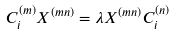<formula> <loc_0><loc_0><loc_500><loc_500>C _ { i } ^ { ( m ) } X ^ { ( m n ) } = \lambda X ^ { ( m n ) } C _ { i } ^ { ( n ) }</formula> 